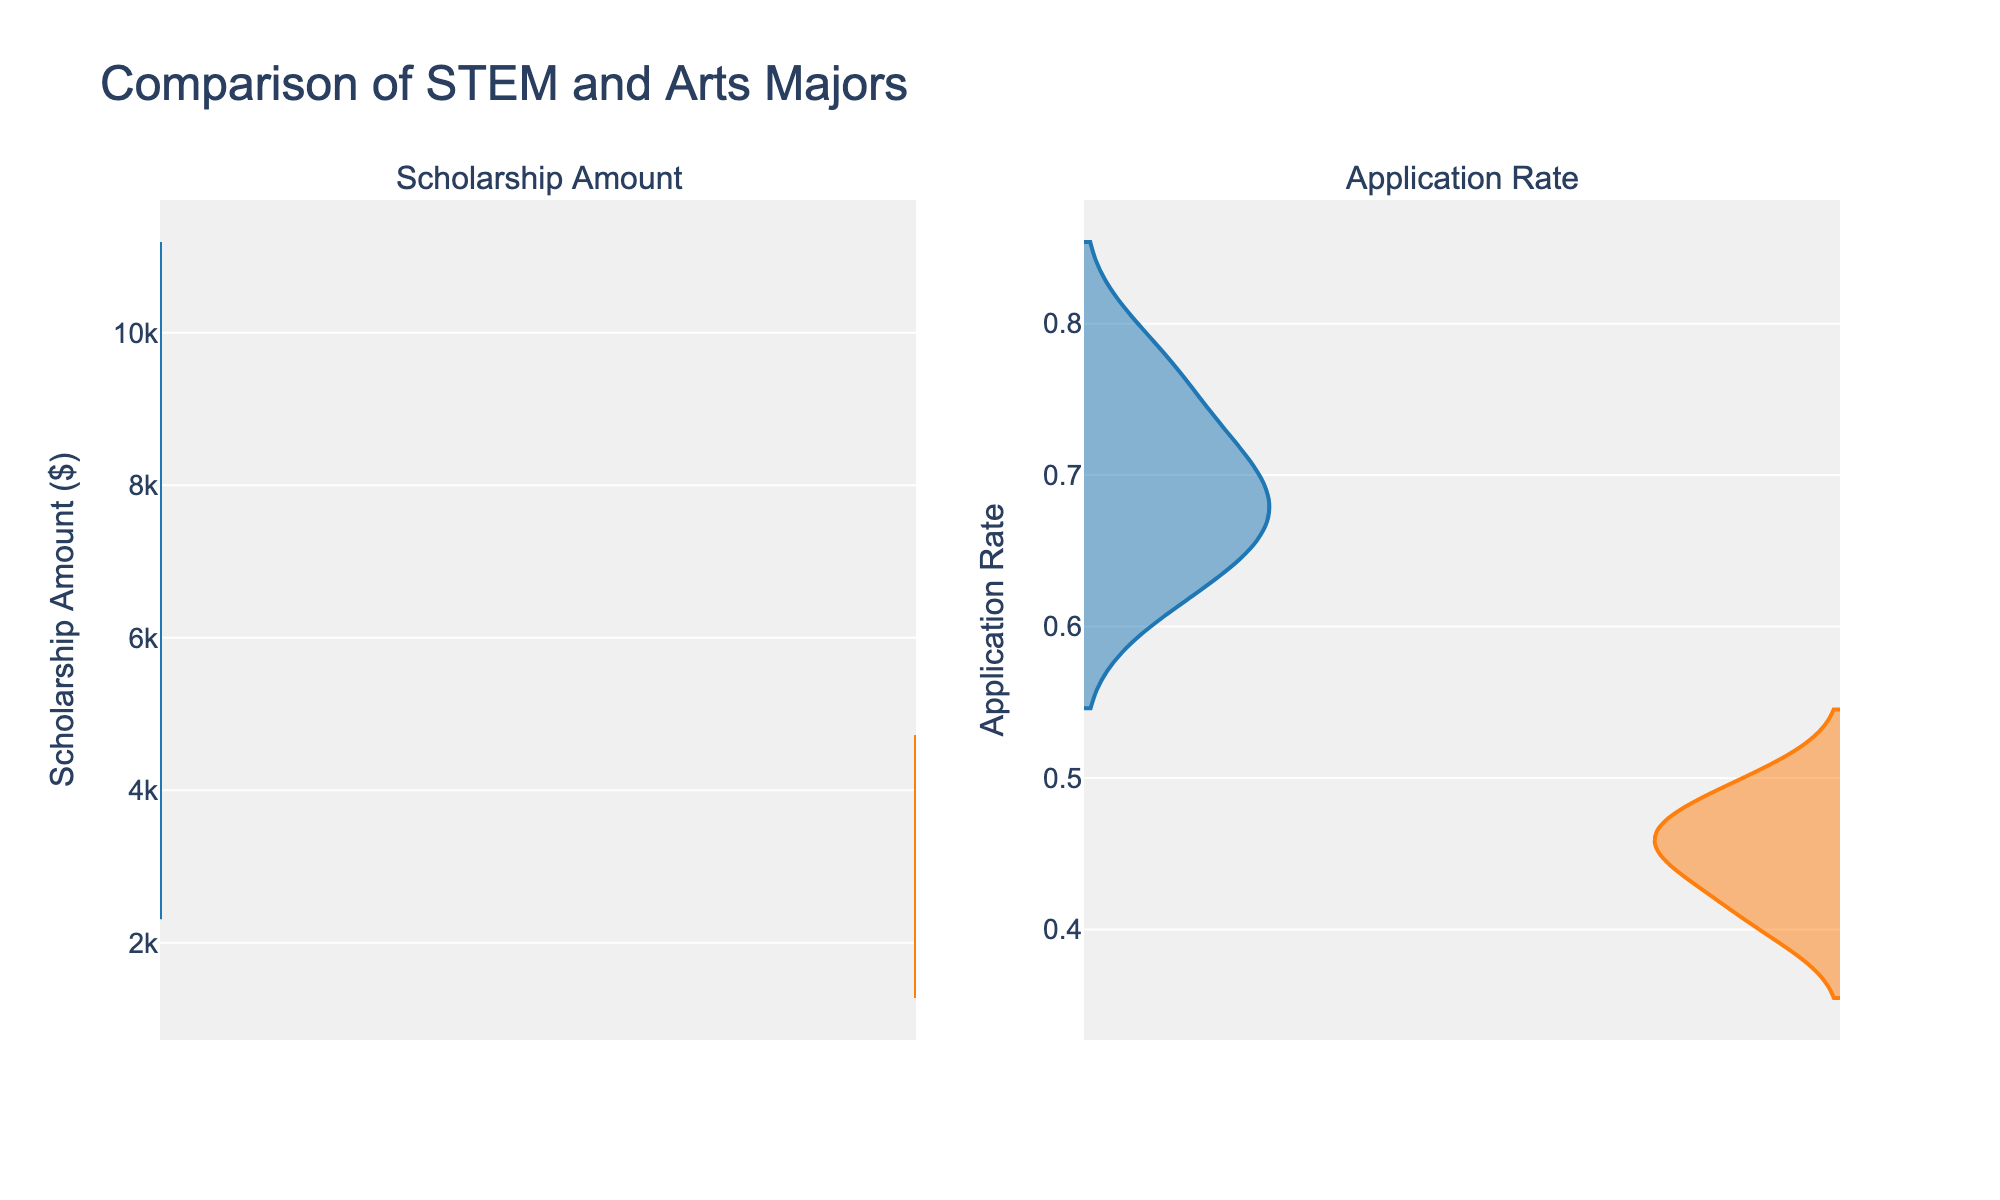Which major has a higher maximum scholarship amount? The violin plot shows that STEM has the higher peak value in scholarship amounts. STEM's highest scholarship amount is $9000, while Arts's highest is $4000.
Answer: STEM Which major has a higher minimum application rate? From the violin plots, the minimum application rate for STEM is 0.62, and for Arts, it is 0.4. So STEM has the higher minimum application rate.
Answer: STEM Which major tends to have lower scholarship amounts? The violin plot for scholarship amounts shows that scholarships for Arts tend to be lower than those for STEM, with Arts ranging from $2000 to $4000 and STEM from $4500 to $9000.
Answer: Arts What is the range of application rates for the Arts major? The range of application rates is the difference between the maximum (0.5) and minimum (0.4) application rates for the Arts major. So, the range is 0.5 - 0.4 = 0.1.
Answer: 0.1 Are the scholarship amounts for STEM more varied than for Arts? By visual inspection of the violin plots, STEM scholarship amounts appear more spread out, ranging from $4500 to $9000, while Arts scholarship amounts are closer together, ranging from $2000 to $4000. This indicates higher variability in STEM scholarship amounts.
Answer: Yes If a student wants to maximize their chances of getting a scholarship, which major should they apply to? The application rates are higher for STEM across the entire distribution, with the lowest point at 0.62 compared to Arts's 0.4.Therefore, applying to STEM would maximize the chance.
Answer: STEM Which major has more consistent application rates? Consistency can be seen by the narrowness of the violin plot. Arts shows a relatively narrower range of application rates from 0.4 to 0.5 compared to the wider range from 0.62 to 0.78 for STEM. Thus, Arts has more consistent application rates.
Answer: Arts What is the median value of scholarship amounts for Arts major? Median value in a violin plot is usually located around the densest area that is most central. For Arts, this area appears to be around $3000.
Answer: $3000 